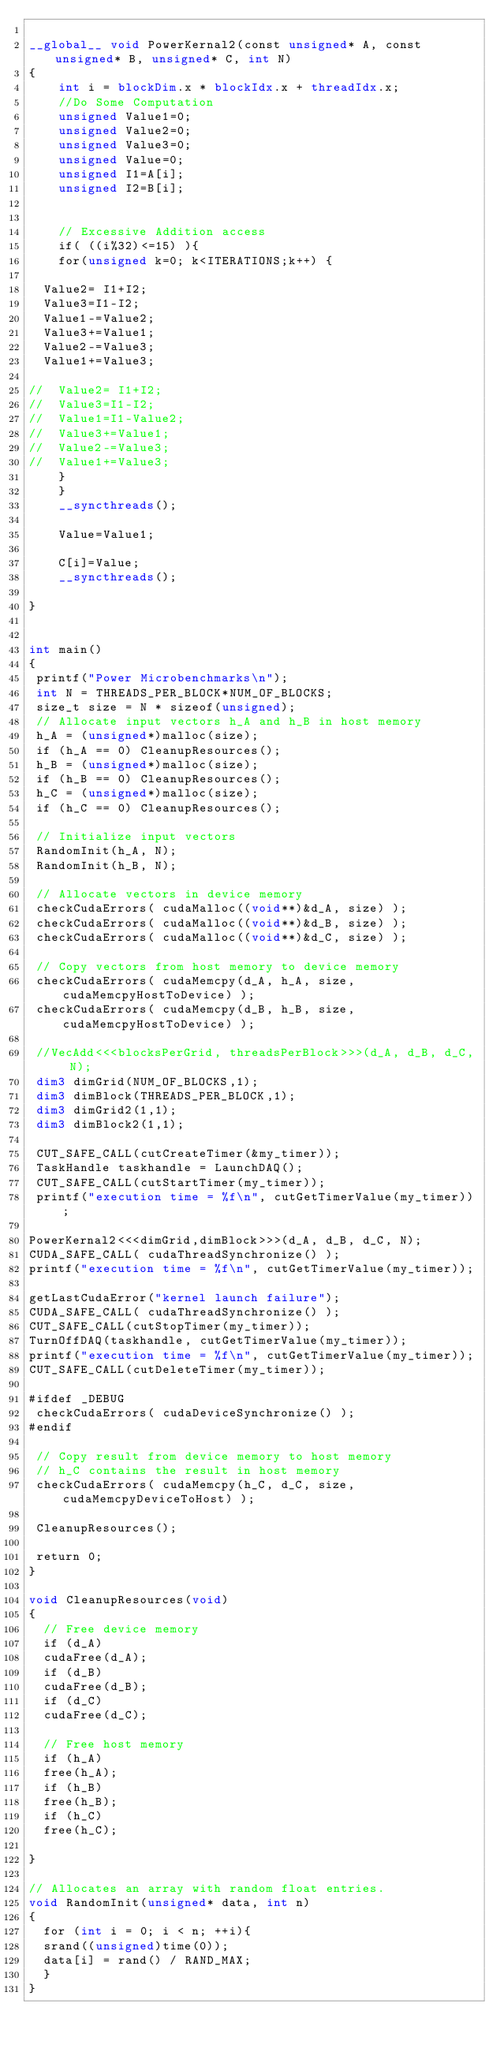<code> <loc_0><loc_0><loc_500><loc_500><_Cuda_>
__global__ void PowerKernal2(const unsigned* A, const unsigned* B, unsigned* C, int N)
{
    int i = blockDim.x * blockIdx.x + threadIdx.x;
    //Do Some Computation
    unsigned Value1=0;
    unsigned Value2=0;
    unsigned Value3=0;
    unsigned Value=0;
    unsigned I1=A[i];
    unsigned I2=B[i];


    // Excessive Addition access
    if( ((i%32)<=15) ){
    for(unsigned k=0; k<ITERATIONS;k++) {

	Value2= I1+I2;
	Value3=I1-I2;
	Value1-=Value2;
	Value3+=Value1;
	Value2-=Value3;
	Value1+=Value3;

//	Value2= I1+I2;
//	Value3=I1-I2;
//	Value1=I1-Value2;
//	Value3+=Value1;
//	Value2-=Value3;
//	Value1+=Value3;
    }
    }
    __syncthreads();
 
    Value=Value1;

    C[i]=Value;
    __syncthreads();

}


int main()
{
 printf("Power Microbenchmarks\n");
 int N = THREADS_PER_BLOCK*NUM_OF_BLOCKS;
 size_t size = N * sizeof(unsigned);
 // Allocate input vectors h_A and h_B in host memory
 h_A = (unsigned*)malloc(size);
 if (h_A == 0) CleanupResources();
 h_B = (unsigned*)malloc(size);
 if (h_B == 0) CleanupResources();
 h_C = (unsigned*)malloc(size);
 if (h_C == 0) CleanupResources();

 // Initialize input vectors
 RandomInit(h_A, N);
 RandomInit(h_B, N);

 // Allocate vectors in device memory
 checkCudaErrors( cudaMalloc((void**)&d_A, size) );
 checkCudaErrors( cudaMalloc((void**)&d_B, size) );
 checkCudaErrors( cudaMalloc((void**)&d_C, size) );

 // Copy vectors from host memory to device memory
 checkCudaErrors( cudaMemcpy(d_A, h_A, size, cudaMemcpyHostToDevice) );
 checkCudaErrors( cudaMemcpy(d_B, h_B, size, cudaMemcpyHostToDevice) );

 //VecAdd<<<blocksPerGrid, threadsPerBlock>>>(d_A, d_B, d_C, N);
 dim3 dimGrid(NUM_OF_BLOCKS,1);
 dim3 dimBlock(THREADS_PER_BLOCK,1);
 dim3 dimGrid2(1,1);
 dim3 dimBlock2(1,1);

 CUT_SAFE_CALL(cutCreateTimer(&my_timer)); 
 TaskHandle taskhandle = LaunchDAQ();
 CUT_SAFE_CALL(cutStartTimer(my_timer)); 
 printf("execution time = %f\n", cutGetTimerValue(my_timer));

PowerKernal2<<<dimGrid,dimBlock>>>(d_A, d_B, d_C, N);
CUDA_SAFE_CALL( cudaThreadSynchronize() );
printf("execution time = %f\n", cutGetTimerValue(my_timer));

getLastCudaError("kernel launch failure");
CUDA_SAFE_CALL( cudaThreadSynchronize() );
CUT_SAFE_CALL(cutStopTimer(my_timer));
TurnOffDAQ(taskhandle, cutGetTimerValue(my_timer));
printf("execution time = %f\n", cutGetTimerValue(my_timer));
CUT_SAFE_CALL(cutDeleteTimer(my_timer)); 

#ifdef _DEBUG
 checkCudaErrors( cudaDeviceSynchronize() );
#endif

 // Copy result from device memory to host memory
 // h_C contains the result in host memory
 checkCudaErrors( cudaMemcpy(h_C, d_C, size, cudaMemcpyDeviceToHost) );
 
 CleanupResources();

 return 0;
}

void CleanupResources(void)
{
  // Free device memory
  if (d_A)
	cudaFree(d_A);
  if (d_B)
	cudaFree(d_B);
  if (d_C)
	cudaFree(d_C);

  // Free host memory
  if (h_A)
	free(h_A);
  if (h_B)
	free(h_B);
  if (h_C)
	free(h_C);

}

// Allocates an array with random float entries.
void RandomInit(unsigned* data, int n)
{
  for (int i = 0; i < n; ++i){
	srand((unsigned)time(0));  
	data[i] = rand() / RAND_MAX;
  }
}






</code> 